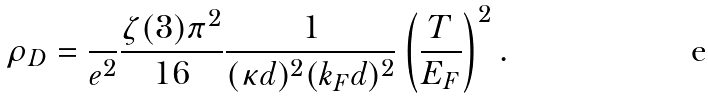<formula> <loc_0><loc_0><loc_500><loc_500>\rho _ { D } = \frac { } { e ^ { 2 } } \frac { \zeta ( 3 ) \pi ^ { 2 } } { 1 6 } \frac { 1 } { ( \kappa d ) ^ { 2 } ( k _ { F } d ) ^ { 2 } } \left ( \frac { T } { E _ { F } } \right ) ^ { 2 } .</formula> 